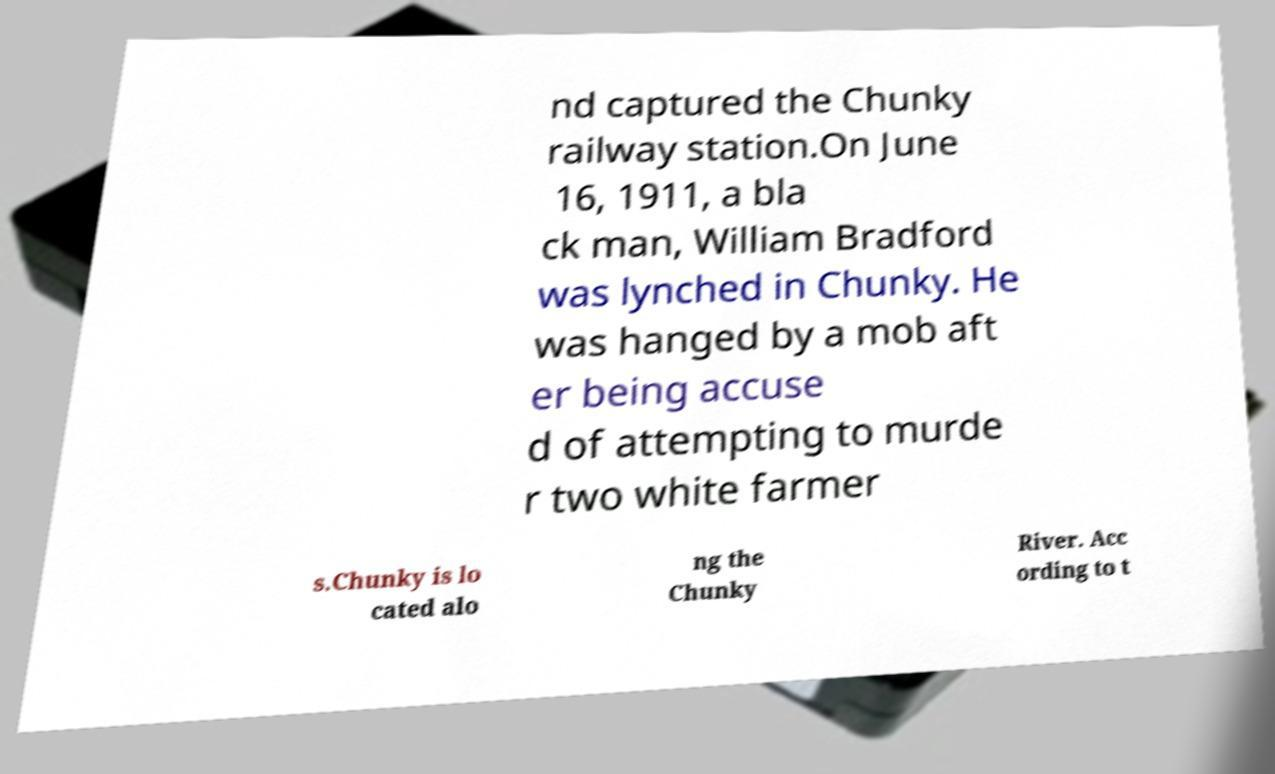There's text embedded in this image that I need extracted. Can you transcribe it verbatim? nd captured the Chunky railway station.On June 16, 1911, a bla ck man, William Bradford was lynched in Chunky. He was hanged by a mob aft er being accuse d of attempting to murde r two white farmer s.Chunky is lo cated alo ng the Chunky River. Acc ording to t 